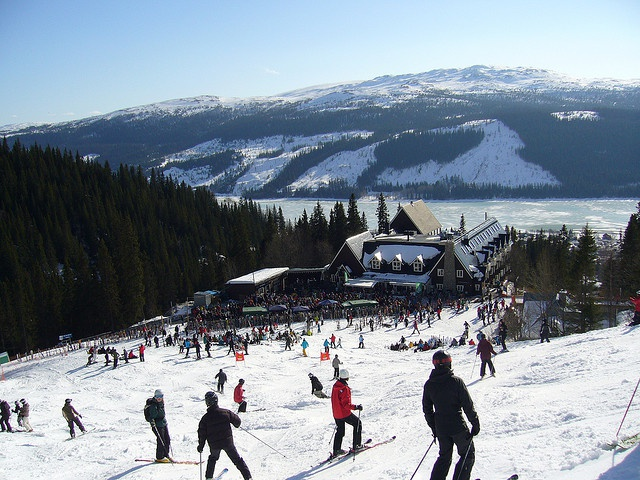Describe the objects in this image and their specific colors. I can see people in gray, black, lightgray, and darkgray tones, people in gray, black, white, and darkgray tones, people in gray, black, white, and darkgray tones, people in gray, black, brown, maroon, and lightgray tones, and people in gray, black, and darkgray tones in this image. 